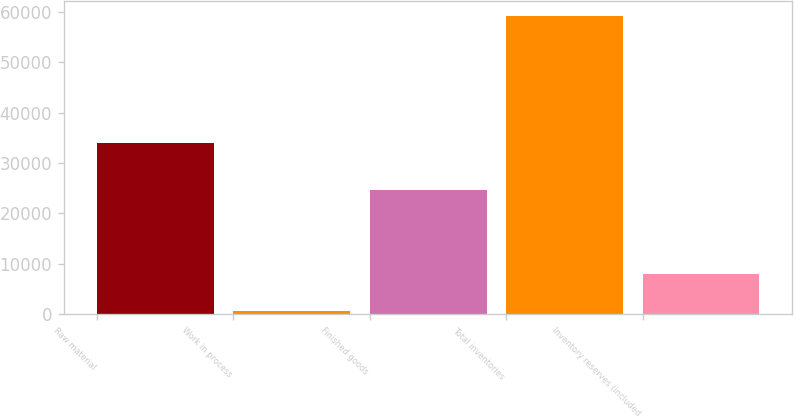Convert chart. <chart><loc_0><loc_0><loc_500><loc_500><bar_chart><fcel>Raw material<fcel>Work in process<fcel>Finished goods<fcel>Total inventories<fcel>Inventory reserves (included<nl><fcel>34041<fcel>569<fcel>24645<fcel>59255<fcel>8037<nl></chart> 